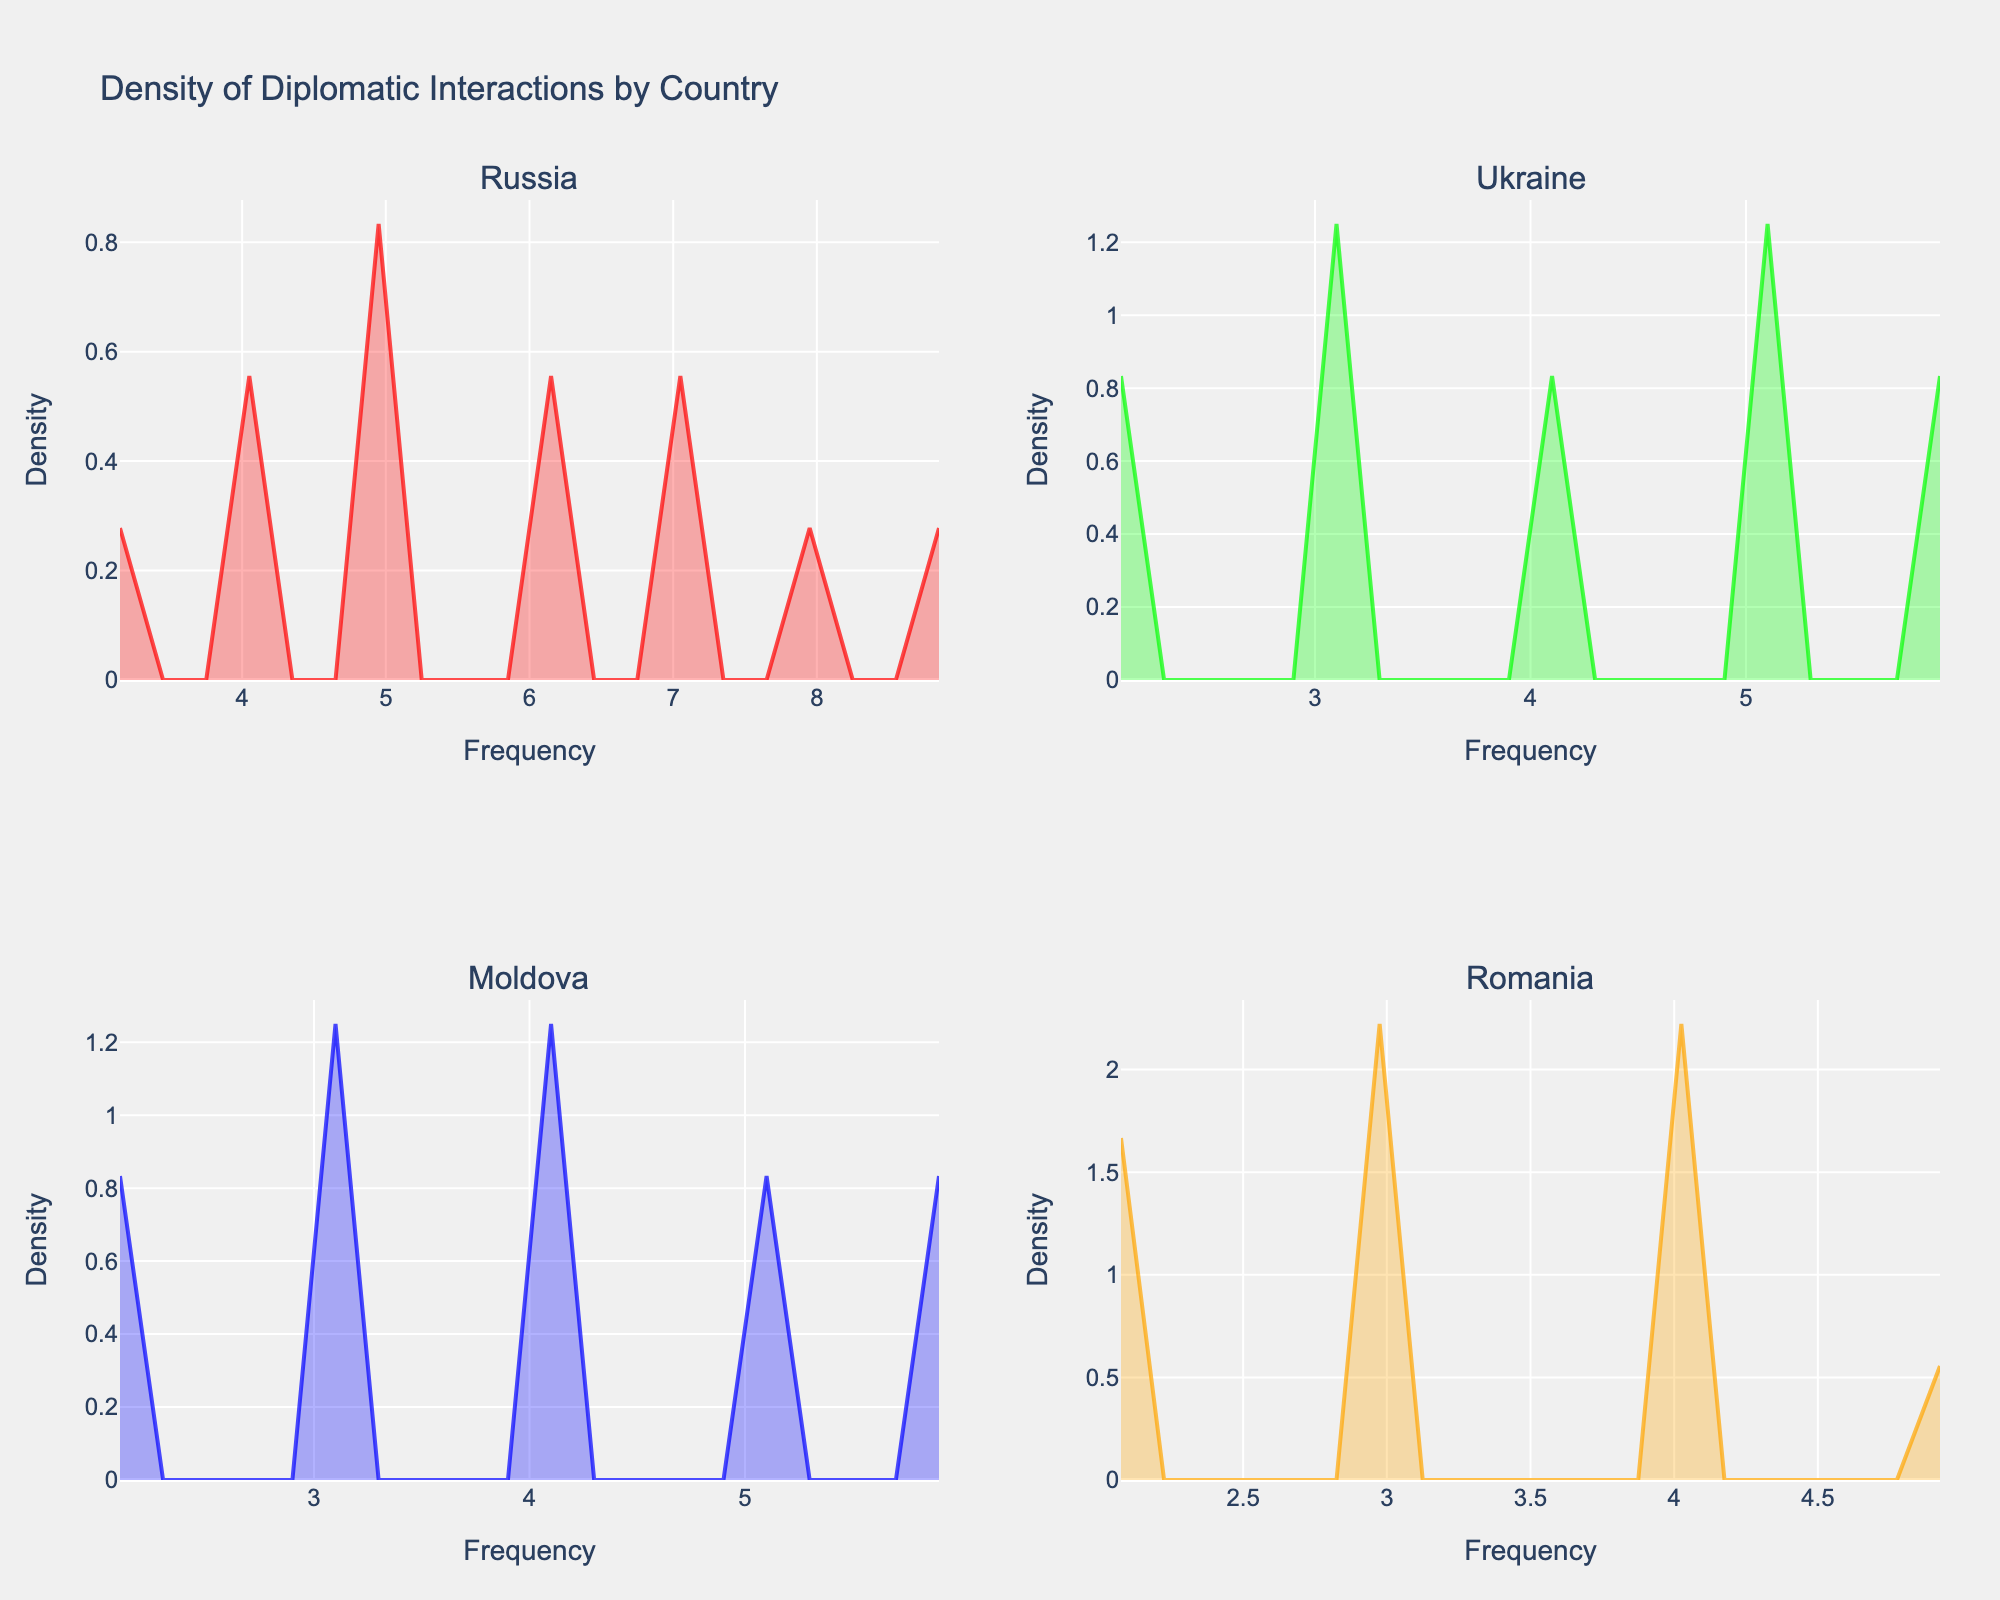What does the title of the figure indicate? The title of the figure "Density of Diplomatic Interactions by Country" indicates that the plot is showing the density distribution of diplomatic interactions of Transnistria with various countries
Answer: Density of Diplomatic Interactions by Country Which country has the widest range of frequency for diplomatic interactions? To determine the range of frequencies for each country, look at the x-axes of each subplot. The country with the widest spread on the x-axis has the widest range of frequencies
Answer: Russia Which country shows the highest peak in density for diplomatic interactions? Identify the highest peak in the y-axis within each subplot, and compare them to find which country has the highest peak overall
Answer: Russia How does the density of diplomatic interactions with Ukraine compare to Moldova in terms of frequency concentration? Compare the density plot of Ukraine to Moldova by examining how the frequencies are distributed; Ukraine's density is more centered around lower frequencies whereas Moldova's density is more spread
Answer: Ukraine is more concentrated at lower frequencies Are there any similarities between the density plots of Romania and Moldova? Look at the shape, peak, and spread of the density plots for both Romania and Moldova. Identify if there are any common patterns or similar distribution characteristics
Answer: Both have similar density peaks around the mid-frequency range What is the approximate frequency where Russia's diplomatic interactions are most dense? Identify the highest point on Russia's density plot and refer to the corresponding frequency on the x-axis
Answer: Approximately 6-7 During which months does Ukraine have a lower frequency of diplomatic interactions compared to its peaks? Identify peaks in Ukraine's frequency and then refer to the months with comparatively lower frequencies as shown in the data
Answer: June and September What can be inferred about the trend of diplomatic interactions between Transnistria and Romania? Look at the density distribution for Romania; note the spread and any significant peaks or patterns in frequencies
Answer: The interactions are relatively evenly distributed with no extreme peaks Which country has more variability in their diplomatic interactions, Russia or Ukraine? Reflex on the density plots' spread and see which country has a larger range of frequency and variability. Russia will show higher variability due to a broader distribution of frequencies
Answer: Russia Considering all the countries, which month generally sees the highest diplomatic interactions overall? Refer to the dataset and sum up the frequencies for each month across all countries to see which month has the highest total interactions
Answer: December 